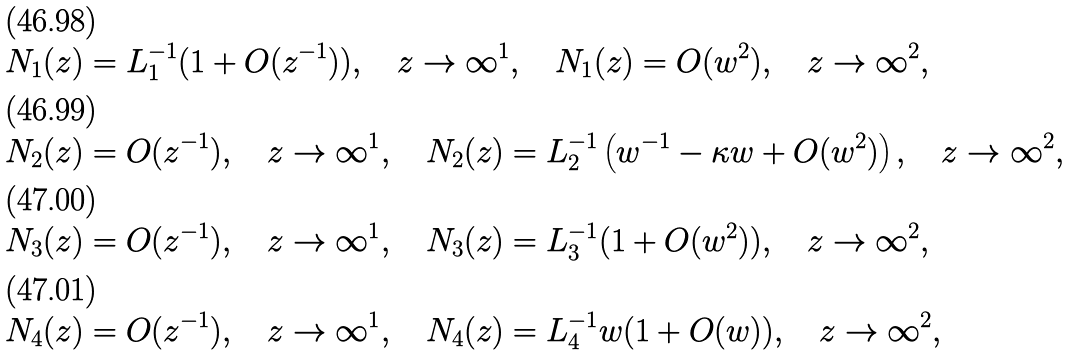Convert formula to latex. <formula><loc_0><loc_0><loc_500><loc_500>N _ { 1 } ( z ) & = L _ { 1 } ^ { - 1 } ( 1 + O ( z ^ { - 1 } ) ) , \quad z \rightarrow \infty ^ { 1 } , \quad N _ { 1 } ( z ) = O ( w ^ { 2 } ) , \quad z \rightarrow \infty ^ { 2 } , \\ N _ { 2 } ( z ) & = O ( z ^ { - 1 } ) , \quad z \rightarrow \infty ^ { 1 } , \quad N _ { 2 } ( z ) = L _ { 2 } ^ { - 1 } \left ( w ^ { - 1 } - \kappa w + O ( w ^ { 2 } ) \right ) , \quad z \rightarrow \infty ^ { 2 } , \\ N _ { 3 } ( z ) & = O ( z ^ { - 1 } ) , \quad z \rightarrow \infty ^ { 1 } , \quad N _ { 3 } ( z ) = L _ { 3 } ^ { - 1 } ( 1 + O ( w ^ { 2 } ) ) , \quad z \rightarrow \infty ^ { 2 } , \\ N _ { 4 } ( z ) & = O ( z ^ { - 1 } ) , \quad z \rightarrow \infty ^ { 1 } , \quad N _ { 4 } ( z ) = L _ { 4 } ^ { - 1 } w ( 1 + O ( w ) ) , \quad z \rightarrow \infty ^ { 2 } ,</formula> 